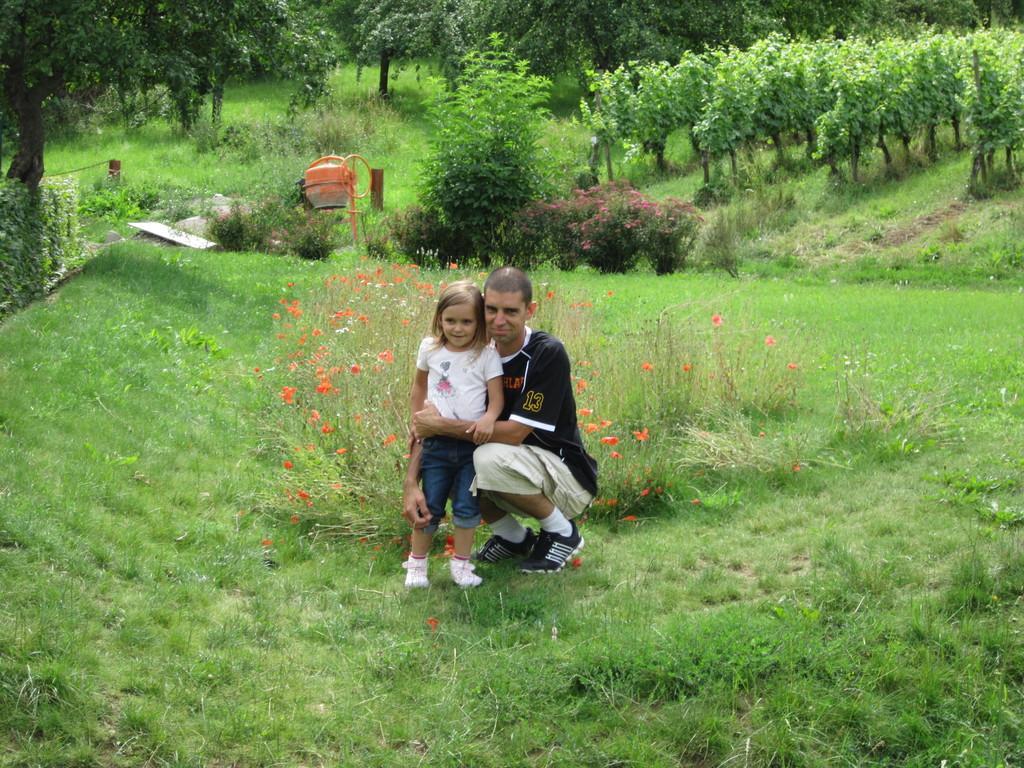Describe this image in one or two sentences. In this image we can see two persons, there are some trees, plants, flowers, grass and some other objects on the ground. 